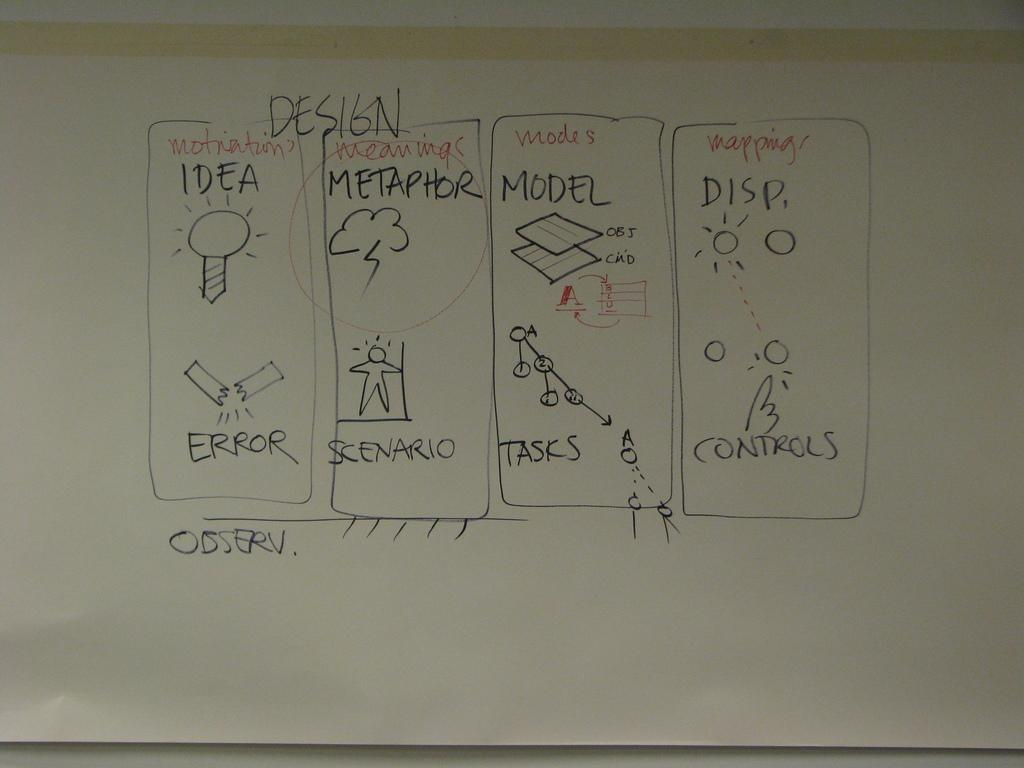<image>
Write a terse but informative summary of the picture. A whiteboard says Design at the top and has four boxes of information. 